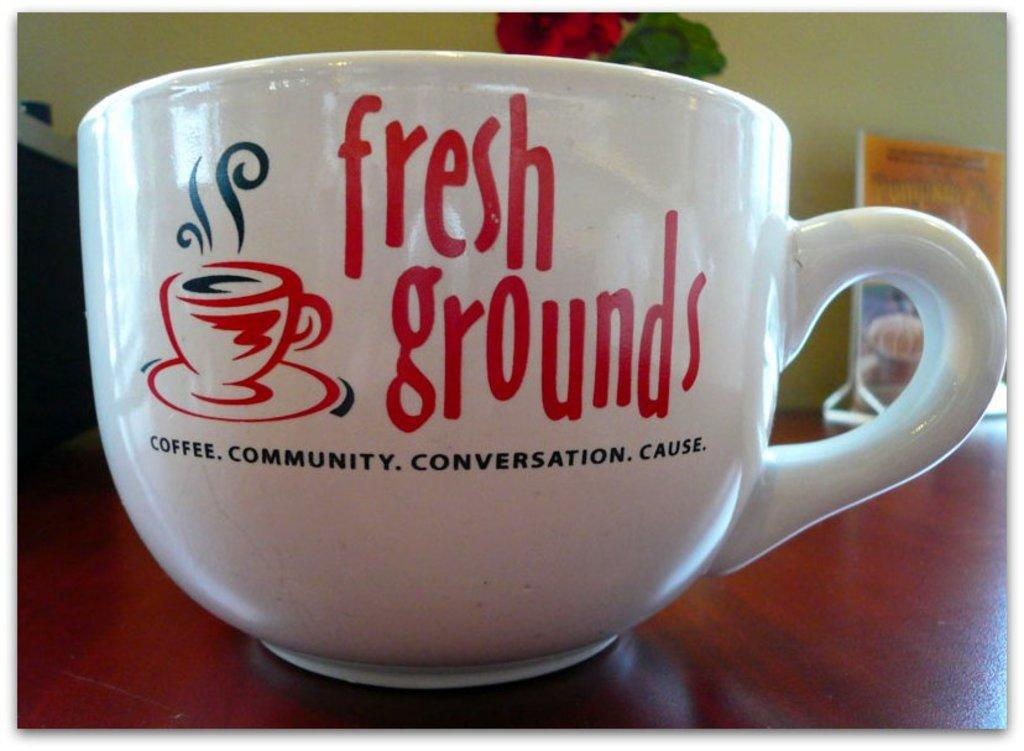<image>
Offer a succinct explanation of the picture presented. A coffee cup has the words "fresh grounds." 